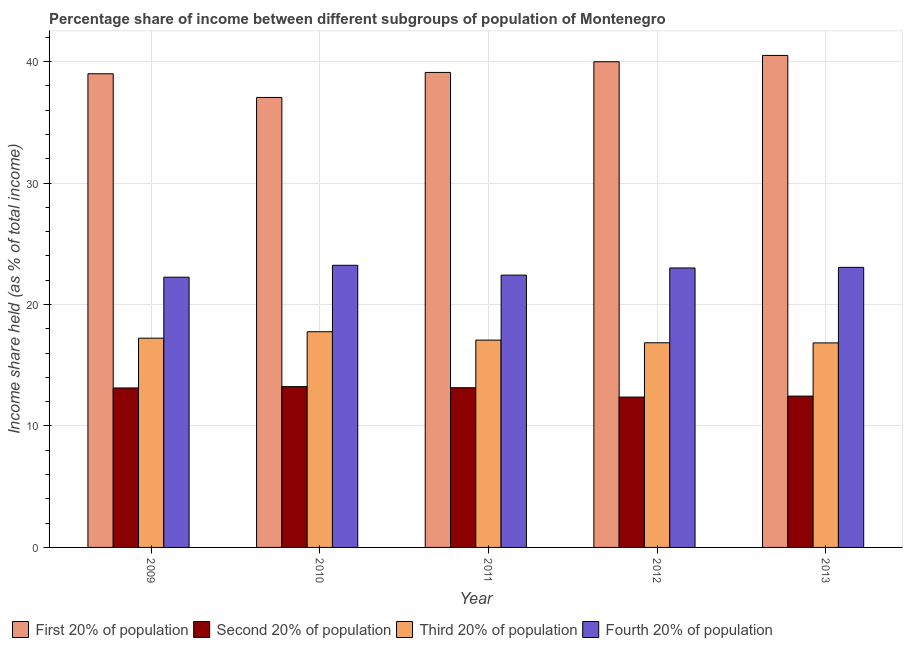How many different coloured bars are there?
Provide a succinct answer. 4. Are the number of bars per tick equal to the number of legend labels?
Keep it short and to the point. Yes. Are the number of bars on each tick of the X-axis equal?
Provide a short and direct response. Yes. How many bars are there on the 4th tick from the left?
Your response must be concise. 4. What is the label of the 4th group of bars from the left?
Provide a succinct answer. 2012. What is the share of the income held by first 20% of the population in 2013?
Keep it short and to the point. 40.51. Across all years, what is the maximum share of the income held by first 20% of the population?
Keep it short and to the point. 40.51. Across all years, what is the minimum share of the income held by first 20% of the population?
Your answer should be compact. 37.05. In which year was the share of the income held by fourth 20% of the population minimum?
Your answer should be very brief. 2009. What is the total share of the income held by third 20% of the population in the graph?
Give a very brief answer. 85.75. What is the difference between the share of the income held by fourth 20% of the population in 2012 and that in 2013?
Your answer should be very brief. -0.05. What is the difference between the share of the income held by fourth 20% of the population in 2012 and the share of the income held by first 20% of the population in 2013?
Offer a very short reply. -0.05. What is the average share of the income held by second 20% of the population per year?
Offer a very short reply. 12.87. In the year 2009, what is the difference between the share of the income held by first 20% of the population and share of the income held by fourth 20% of the population?
Your answer should be very brief. 0. In how many years, is the share of the income held by second 20% of the population greater than 38 %?
Offer a terse response. 0. What is the ratio of the share of the income held by fourth 20% of the population in 2012 to that in 2013?
Your response must be concise. 1. Is the share of the income held by first 20% of the population in 2009 less than that in 2012?
Offer a very short reply. Yes. What is the difference between the highest and the second highest share of the income held by first 20% of the population?
Your answer should be compact. 0.52. What is the difference between the highest and the lowest share of the income held by first 20% of the population?
Your response must be concise. 3.46. What does the 3rd bar from the left in 2013 represents?
Keep it short and to the point. Third 20% of population. What does the 1st bar from the right in 2011 represents?
Provide a short and direct response. Fourth 20% of population. How many bars are there?
Provide a succinct answer. 20. Are all the bars in the graph horizontal?
Keep it short and to the point. No. How many years are there in the graph?
Provide a succinct answer. 5. What is the difference between two consecutive major ticks on the Y-axis?
Your answer should be very brief. 10. Are the values on the major ticks of Y-axis written in scientific E-notation?
Offer a very short reply. No. How many legend labels are there?
Provide a short and direct response. 4. How are the legend labels stacked?
Your answer should be very brief. Horizontal. What is the title of the graph?
Offer a very short reply. Percentage share of income between different subgroups of population of Montenegro. What is the label or title of the Y-axis?
Keep it short and to the point. Income share held (as % of total income). What is the Income share held (as % of total income) of First 20% of population in 2009?
Offer a terse response. 39. What is the Income share held (as % of total income) of Second 20% of population in 2009?
Make the answer very short. 13.13. What is the Income share held (as % of total income) of Third 20% of population in 2009?
Your answer should be very brief. 17.23. What is the Income share held (as % of total income) in Fourth 20% of population in 2009?
Your response must be concise. 22.25. What is the Income share held (as % of total income) of First 20% of population in 2010?
Provide a short and direct response. 37.05. What is the Income share held (as % of total income) in Second 20% of population in 2010?
Ensure brevity in your answer.  13.24. What is the Income share held (as % of total income) of Third 20% of population in 2010?
Give a very brief answer. 17.76. What is the Income share held (as % of total income) of Fourth 20% of population in 2010?
Ensure brevity in your answer.  23.23. What is the Income share held (as % of total income) of First 20% of population in 2011?
Offer a very short reply. 39.11. What is the Income share held (as % of total income) in Second 20% of population in 2011?
Your answer should be very brief. 13.15. What is the Income share held (as % of total income) in Third 20% of population in 2011?
Your response must be concise. 17.07. What is the Income share held (as % of total income) in Fourth 20% of population in 2011?
Your answer should be compact. 22.42. What is the Income share held (as % of total income) of First 20% of population in 2012?
Ensure brevity in your answer.  39.99. What is the Income share held (as % of total income) in Second 20% of population in 2012?
Offer a terse response. 12.38. What is the Income share held (as % of total income) in Third 20% of population in 2012?
Your answer should be very brief. 16.85. What is the Income share held (as % of total income) of Fourth 20% of population in 2012?
Provide a short and direct response. 23.01. What is the Income share held (as % of total income) in First 20% of population in 2013?
Provide a succinct answer. 40.51. What is the Income share held (as % of total income) of Second 20% of population in 2013?
Make the answer very short. 12.46. What is the Income share held (as % of total income) of Third 20% of population in 2013?
Provide a short and direct response. 16.84. What is the Income share held (as % of total income) in Fourth 20% of population in 2013?
Ensure brevity in your answer.  23.06. Across all years, what is the maximum Income share held (as % of total income) in First 20% of population?
Offer a very short reply. 40.51. Across all years, what is the maximum Income share held (as % of total income) in Second 20% of population?
Your answer should be compact. 13.24. Across all years, what is the maximum Income share held (as % of total income) of Third 20% of population?
Offer a very short reply. 17.76. Across all years, what is the maximum Income share held (as % of total income) of Fourth 20% of population?
Keep it short and to the point. 23.23. Across all years, what is the minimum Income share held (as % of total income) of First 20% of population?
Your answer should be very brief. 37.05. Across all years, what is the minimum Income share held (as % of total income) of Second 20% of population?
Ensure brevity in your answer.  12.38. Across all years, what is the minimum Income share held (as % of total income) of Third 20% of population?
Offer a terse response. 16.84. Across all years, what is the minimum Income share held (as % of total income) in Fourth 20% of population?
Provide a succinct answer. 22.25. What is the total Income share held (as % of total income) in First 20% of population in the graph?
Keep it short and to the point. 195.66. What is the total Income share held (as % of total income) in Second 20% of population in the graph?
Provide a succinct answer. 64.36. What is the total Income share held (as % of total income) of Third 20% of population in the graph?
Make the answer very short. 85.75. What is the total Income share held (as % of total income) of Fourth 20% of population in the graph?
Give a very brief answer. 113.97. What is the difference between the Income share held (as % of total income) of First 20% of population in 2009 and that in 2010?
Give a very brief answer. 1.95. What is the difference between the Income share held (as % of total income) of Second 20% of population in 2009 and that in 2010?
Give a very brief answer. -0.11. What is the difference between the Income share held (as % of total income) of Third 20% of population in 2009 and that in 2010?
Provide a short and direct response. -0.53. What is the difference between the Income share held (as % of total income) in Fourth 20% of population in 2009 and that in 2010?
Your response must be concise. -0.98. What is the difference between the Income share held (as % of total income) in First 20% of population in 2009 and that in 2011?
Give a very brief answer. -0.11. What is the difference between the Income share held (as % of total income) in Second 20% of population in 2009 and that in 2011?
Offer a very short reply. -0.02. What is the difference between the Income share held (as % of total income) in Third 20% of population in 2009 and that in 2011?
Provide a short and direct response. 0.16. What is the difference between the Income share held (as % of total income) of Fourth 20% of population in 2009 and that in 2011?
Your response must be concise. -0.17. What is the difference between the Income share held (as % of total income) in First 20% of population in 2009 and that in 2012?
Offer a terse response. -0.99. What is the difference between the Income share held (as % of total income) in Third 20% of population in 2009 and that in 2012?
Provide a short and direct response. 0.38. What is the difference between the Income share held (as % of total income) of Fourth 20% of population in 2009 and that in 2012?
Give a very brief answer. -0.76. What is the difference between the Income share held (as % of total income) in First 20% of population in 2009 and that in 2013?
Provide a short and direct response. -1.51. What is the difference between the Income share held (as % of total income) in Second 20% of population in 2009 and that in 2013?
Provide a short and direct response. 0.67. What is the difference between the Income share held (as % of total income) in Third 20% of population in 2009 and that in 2013?
Provide a succinct answer. 0.39. What is the difference between the Income share held (as % of total income) in Fourth 20% of population in 2009 and that in 2013?
Keep it short and to the point. -0.81. What is the difference between the Income share held (as % of total income) in First 20% of population in 2010 and that in 2011?
Your answer should be compact. -2.06. What is the difference between the Income share held (as % of total income) in Second 20% of population in 2010 and that in 2011?
Keep it short and to the point. 0.09. What is the difference between the Income share held (as % of total income) of Third 20% of population in 2010 and that in 2011?
Offer a terse response. 0.69. What is the difference between the Income share held (as % of total income) of Fourth 20% of population in 2010 and that in 2011?
Offer a very short reply. 0.81. What is the difference between the Income share held (as % of total income) of First 20% of population in 2010 and that in 2012?
Offer a very short reply. -2.94. What is the difference between the Income share held (as % of total income) of Second 20% of population in 2010 and that in 2012?
Give a very brief answer. 0.86. What is the difference between the Income share held (as % of total income) of Third 20% of population in 2010 and that in 2012?
Keep it short and to the point. 0.91. What is the difference between the Income share held (as % of total income) of Fourth 20% of population in 2010 and that in 2012?
Your response must be concise. 0.22. What is the difference between the Income share held (as % of total income) in First 20% of population in 2010 and that in 2013?
Make the answer very short. -3.46. What is the difference between the Income share held (as % of total income) in Second 20% of population in 2010 and that in 2013?
Provide a succinct answer. 0.78. What is the difference between the Income share held (as % of total income) of Fourth 20% of population in 2010 and that in 2013?
Keep it short and to the point. 0.17. What is the difference between the Income share held (as % of total income) in First 20% of population in 2011 and that in 2012?
Make the answer very short. -0.88. What is the difference between the Income share held (as % of total income) in Second 20% of population in 2011 and that in 2012?
Give a very brief answer. 0.77. What is the difference between the Income share held (as % of total income) of Third 20% of population in 2011 and that in 2012?
Your answer should be compact. 0.22. What is the difference between the Income share held (as % of total income) of Fourth 20% of population in 2011 and that in 2012?
Keep it short and to the point. -0.59. What is the difference between the Income share held (as % of total income) of First 20% of population in 2011 and that in 2013?
Provide a succinct answer. -1.4. What is the difference between the Income share held (as % of total income) of Second 20% of population in 2011 and that in 2013?
Provide a short and direct response. 0.69. What is the difference between the Income share held (as % of total income) of Third 20% of population in 2011 and that in 2013?
Your answer should be compact. 0.23. What is the difference between the Income share held (as % of total income) of Fourth 20% of population in 2011 and that in 2013?
Make the answer very short. -0.64. What is the difference between the Income share held (as % of total income) of First 20% of population in 2012 and that in 2013?
Make the answer very short. -0.52. What is the difference between the Income share held (as % of total income) in Second 20% of population in 2012 and that in 2013?
Offer a terse response. -0.08. What is the difference between the Income share held (as % of total income) of Third 20% of population in 2012 and that in 2013?
Make the answer very short. 0.01. What is the difference between the Income share held (as % of total income) in First 20% of population in 2009 and the Income share held (as % of total income) in Second 20% of population in 2010?
Give a very brief answer. 25.76. What is the difference between the Income share held (as % of total income) of First 20% of population in 2009 and the Income share held (as % of total income) of Third 20% of population in 2010?
Your response must be concise. 21.24. What is the difference between the Income share held (as % of total income) of First 20% of population in 2009 and the Income share held (as % of total income) of Fourth 20% of population in 2010?
Your answer should be compact. 15.77. What is the difference between the Income share held (as % of total income) in Second 20% of population in 2009 and the Income share held (as % of total income) in Third 20% of population in 2010?
Make the answer very short. -4.63. What is the difference between the Income share held (as % of total income) of Third 20% of population in 2009 and the Income share held (as % of total income) of Fourth 20% of population in 2010?
Your answer should be very brief. -6. What is the difference between the Income share held (as % of total income) in First 20% of population in 2009 and the Income share held (as % of total income) in Second 20% of population in 2011?
Keep it short and to the point. 25.85. What is the difference between the Income share held (as % of total income) of First 20% of population in 2009 and the Income share held (as % of total income) of Third 20% of population in 2011?
Make the answer very short. 21.93. What is the difference between the Income share held (as % of total income) in First 20% of population in 2009 and the Income share held (as % of total income) in Fourth 20% of population in 2011?
Offer a terse response. 16.58. What is the difference between the Income share held (as % of total income) of Second 20% of population in 2009 and the Income share held (as % of total income) of Third 20% of population in 2011?
Your response must be concise. -3.94. What is the difference between the Income share held (as % of total income) in Second 20% of population in 2009 and the Income share held (as % of total income) in Fourth 20% of population in 2011?
Provide a short and direct response. -9.29. What is the difference between the Income share held (as % of total income) in Third 20% of population in 2009 and the Income share held (as % of total income) in Fourth 20% of population in 2011?
Give a very brief answer. -5.19. What is the difference between the Income share held (as % of total income) in First 20% of population in 2009 and the Income share held (as % of total income) in Second 20% of population in 2012?
Your response must be concise. 26.62. What is the difference between the Income share held (as % of total income) of First 20% of population in 2009 and the Income share held (as % of total income) of Third 20% of population in 2012?
Your response must be concise. 22.15. What is the difference between the Income share held (as % of total income) in First 20% of population in 2009 and the Income share held (as % of total income) in Fourth 20% of population in 2012?
Your response must be concise. 15.99. What is the difference between the Income share held (as % of total income) of Second 20% of population in 2009 and the Income share held (as % of total income) of Third 20% of population in 2012?
Ensure brevity in your answer.  -3.72. What is the difference between the Income share held (as % of total income) in Second 20% of population in 2009 and the Income share held (as % of total income) in Fourth 20% of population in 2012?
Offer a terse response. -9.88. What is the difference between the Income share held (as % of total income) in Third 20% of population in 2009 and the Income share held (as % of total income) in Fourth 20% of population in 2012?
Give a very brief answer. -5.78. What is the difference between the Income share held (as % of total income) in First 20% of population in 2009 and the Income share held (as % of total income) in Second 20% of population in 2013?
Keep it short and to the point. 26.54. What is the difference between the Income share held (as % of total income) in First 20% of population in 2009 and the Income share held (as % of total income) in Third 20% of population in 2013?
Your answer should be very brief. 22.16. What is the difference between the Income share held (as % of total income) of First 20% of population in 2009 and the Income share held (as % of total income) of Fourth 20% of population in 2013?
Provide a succinct answer. 15.94. What is the difference between the Income share held (as % of total income) in Second 20% of population in 2009 and the Income share held (as % of total income) in Third 20% of population in 2013?
Ensure brevity in your answer.  -3.71. What is the difference between the Income share held (as % of total income) in Second 20% of population in 2009 and the Income share held (as % of total income) in Fourth 20% of population in 2013?
Your response must be concise. -9.93. What is the difference between the Income share held (as % of total income) of Third 20% of population in 2009 and the Income share held (as % of total income) of Fourth 20% of population in 2013?
Offer a terse response. -5.83. What is the difference between the Income share held (as % of total income) in First 20% of population in 2010 and the Income share held (as % of total income) in Second 20% of population in 2011?
Your response must be concise. 23.9. What is the difference between the Income share held (as % of total income) in First 20% of population in 2010 and the Income share held (as % of total income) in Third 20% of population in 2011?
Your answer should be compact. 19.98. What is the difference between the Income share held (as % of total income) in First 20% of population in 2010 and the Income share held (as % of total income) in Fourth 20% of population in 2011?
Make the answer very short. 14.63. What is the difference between the Income share held (as % of total income) of Second 20% of population in 2010 and the Income share held (as % of total income) of Third 20% of population in 2011?
Make the answer very short. -3.83. What is the difference between the Income share held (as % of total income) of Second 20% of population in 2010 and the Income share held (as % of total income) of Fourth 20% of population in 2011?
Ensure brevity in your answer.  -9.18. What is the difference between the Income share held (as % of total income) in Third 20% of population in 2010 and the Income share held (as % of total income) in Fourth 20% of population in 2011?
Offer a terse response. -4.66. What is the difference between the Income share held (as % of total income) of First 20% of population in 2010 and the Income share held (as % of total income) of Second 20% of population in 2012?
Give a very brief answer. 24.67. What is the difference between the Income share held (as % of total income) in First 20% of population in 2010 and the Income share held (as % of total income) in Third 20% of population in 2012?
Provide a succinct answer. 20.2. What is the difference between the Income share held (as % of total income) of First 20% of population in 2010 and the Income share held (as % of total income) of Fourth 20% of population in 2012?
Give a very brief answer. 14.04. What is the difference between the Income share held (as % of total income) in Second 20% of population in 2010 and the Income share held (as % of total income) in Third 20% of population in 2012?
Offer a very short reply. -3.61. What is the difference between the Income share held (as % of total income) of Second 20% of population in 2010 and the Income share held (as % of total income) of Fourth 20% of population in 2012?
Make the answer very short. -9.77. What is the difference between the Income share held (as % of total income) in Third 20% of population in 2010 and the Income share held (as % of total income) in Fourth 20% of population in 2012?
Give a very brief answer. -5.25. What is the difference between the Income share held (as % of total income) of First 20% of population in 2010 and the Income share held (as % of total income) of Second 20% of population in 2013?
Provide a succinct answer. 24.59. What is the difference between the Income share held (as % of total income) of First 20% of population in 2010 and the Income share held (as % of total income) of Third 20% of population in 2013?
Your answer should be compact. 20.21. What is the difference between the Income share held (as % of total income) in First 20% of population in 2010 and the Income share held (as % of total income) in Fourth 20% of population in 2013?
Provide a succinct answer. 13.99. What is the difference between the Income share held (as % of total income) of Second 20% of population in 2010 and the Income share held (as % of total income) of Fourth 20% of population in 2013?
Offer a terse response. -9.82. What is the difference between the Income share held (as % of total income) of First 20% of population in 2011 and the Income share held (as % of total income) of Second 20% of population in 2012?
Offer a very short reply. 26.73. What is the difference between the Income share held (as % of total income) of First 20% of population in 2011 and the Income share held (as % of total income) of Third 20% of population in 2012?
Your response must be concise. 22.26. What is the difference between the Income share held (as % of total income) in First 20% of population in 2011 and the Income share held (as % of total income) in Fourth 20% of population in 2012?
Provide a short and direct response. 16.1. What is the difference between the Income share held (as % of total income) in Second 20% of population in 2011 and the Income share held (as % of total income) in Fourth 20% of population in 2012?
Offer a terse response. -9.86. What is the difference between the Income share held (as % of total income) in Third 20% of population in 2011 and the Income share held (as % of total income) in Fourth 20% of population in 2012?
Your response must be concise. -5.94. What is the difference between the Income share held (as % of total income) of First 20% of population in 2011 and the Income share held (as % of total income) of Second 20% of population in 2013?
Make the answer very short. 26.65. What is the difference between the Income share held (as % of total income) in First 20% of population in 2011 and the Income share held (as % of total income) in Third 20% of population in 2013?
Offer a terse response. 22.27. What is the difference between the Income share held (as % of total income) of First 20% of population in 2011 and the Income share held (as % of total income) of Fourth 20% of population in 2013?
Give a very brief answer. 16.05. What is the difference between the Income share held (as % of total income) of Second 20% of population in 2011 and the Income share held (as % of total income) of Third 20% of population in 2013?
Your answer should be very brief. -3.69. What is the difference between the Income share held (as % of total income) of Second 20% of population in 2011 and the Income share held (as % of total income) of Fourth 20% of population in 2013?
Give a very brief answer. -9.91. What is the difference between the Income share held (as % of total income) of Third 20% of population in 2011 and the Income share held (as % of total income) of Fourth 20% of population in 2013?
Your answer should be compact. -5.99. What is the difference between the Income share held (as % of total income) in First 20% of population in 2012 and the Income share held (as % of total income) in Second 20% of population in 2013?
Keep it short and to the point. 27.53. What is the difference between the Income share held (as % of total income) of First 20% of population in 2012 and the Income share held (as % of total income) of Third 20% of population in 2013?
Offer a very short reply. 23.15. What is the difference between the Income share held (as % of total income) of First 20% of population in 2012 and the Income share held (as % of total income) of Fourth 20% of population in 2013?
Give a very brief answer. 16.93. What is the difference between the Income share held (as % of total income) in Second 20% of population in 2012 and the Income share held (as % of total income) in Third 20% of population in 2013?
Keep it short and to the point. -4.46. What is the difference between the Income share held (as % of total income) in Second 20% of population in 2012 and the Income share held (as % of total income) in Fourth 20% of population in 2013?
Keep it short and to the point. -10.68. What is the difference between the Income share held (as % of total income) in Third 20% of population in 2012 and the Income share held (as % of total income) in Fourth 20% of population in 2013?
Make the answer very short. -6.21. What is the average Income share held (as % of total income) of First 20% of population per year?
Make the answer very short. 39.13. What is the average Income share held (as % of total income) in Second 20% of population per year?
Offer a very short reply. 12.87. What is the average Income share held (as % of total income) of Third 20% of population per year?
Make the answer very short. 17.15. What is the average Income share held (as % of total income) of Fourth 20% of population per year?
Offer a terse response. 22.79. In the year 2009, what is the difference between the Income share held (as % of total income) in First 20% of population and Income share held (as % of total income) in Second 20% of population?
Your answer should be very brief. 25.87. In the year 2009, what is the difference between the Income share held (as % of total income) in First 20% of population and Income share held (as % of total income) in Third 20% of population?
Keep it short and to the point. 21.77. In the year 2009, what is the difference between the Income share held (as % of total income) of First 20% of population and Income share held (as % of total income) of Fourth 20% of population?
Provide a short and direct response. 16.75. In the year 2009, what is the difference between the Income share held (as % of total income) of Second 20% of population and Income share held (as % of total income) of Fourth 20% of population?
Provide a succinct answer. -9.12. In the year 2009, what is the difference between the Income share held (as % of total income) of Third 20% of population and Income share held (as % of total income) of Fourth 20% of population?
Your answer should be very brief. -5.02. In the year 2010, what is the difference between the Income share held (as % of total income) of First 20% of population and Income share held (as % of total income) of Second 20% of population?
Your answer should be compact. 23.81. In the year 2010, what is the difference between the Income share held (as % of total income) of First 20% of population and Income share held (as % of total income) of Third 20% of population?
Your response must be concise. 19.29. In the year 2010, what is the difference between the Income share held (as % of total income) in First 20% of population and Income share held (as % of total income) in Fourth 20% of population?
Make the answer very short. 13.82. In the year 2010, what is the difference between the Income share held (as % of total income) of Second 20% of population and Income share held (as % of total income) of Third 20% of population?
Make the answer very short. -4.52. In the year 2010, what is the difference between the Income share held (as % of total income) of Second 20% of population and Income share held (as % of total income) of Fourth 20% of population?
Give a very brief answer. -9.99. In the year 2010, what is the difference between the Income share held (as % of total income) of Third 20% of population and Income share held (as % of total income) of Fourth 20% of population?
Keep it short and to the point. -5.47. In the year 2011, what is the difference between the Income share held (as % of total income) of First 20% of population and Income share held (as % of total income) of Second 20% of population?
Offer a very short reply. 25.96. In the year 2011, what is the difference between the Income share held (as % of total income) in First 20% of population and Income share held (as % of total income) in Third 20% of population?
Keep it short and to the point. 22.04. In the year 2011, what is the difference between the Income share held (as % of total income) in First 20% of population and Income share held (as % of total income) in Fourth 20% of population?
Offer a terse response. 16.69. In the year 2011, what is the difference between the Income share held (as % of total income) of Second 20% of population and Income share held (as % of total income) of Third 20% of population?
Offer a very short reply. -3.92. In the year 2011, what is the difference between the Income share held (as % of total income) in Second 20% of population and Income share held (as % of total income) in Fourth 20% of population?
Provide a succinct answer. -9.27. In the year 2011, what is the difference between the Income share held (as % of total income) in Third 20% of population and Income share held (as % of total income) in Fourth 20% of population?
Your answer should be compact. -5.35. In the year 2012, what is the difference between the Income share held (as % of total income) in First 20% of population and Income share held (as % of total income) in Second 20% of population?
Offer a terse response. 27.61. In the year 2012, what is the difference between the Income share held (as % of total income) of First 20% of population and Income share held (as % of total income) of Third 20% of population?
Provide a succinct answer. 23.14. In the year 2012, what is the difference between the Income share held (as % of total income) in First 20% of population and Income share held (as % of total income) in Fourth 20% of population?
Offer a very short reply. 16.98. In the year 2012, what is the difference between the Income share held (as % of total income) in Second 20% of population and Income share held (as % of total income) in Third 20% of population?
Ensure brevity in your answer.  -4.47. In the year 2012, what is the difference between the Income share held (as % of total income) in Second 20% of population and Income share held (as % of total income) in Fourth 20% of population?
Offer a terse response. -10.63. In the year 2012, what is the difference between the Income share held (as % of total income) in Third 20% of population and Income share held (as % of total income) in Fourth 20% of population?
Provide a short and direct response. -6.16. In the year 2013, what is the difference between the Income share held (as % of total income) in First 20% of population and Income share held (as % of total income) in Second 20% of population?
Give a very brief answer. 28.05. In the year 2013, what is the difference between the Income share held (as % of total income) in First 20% of population and Income share held (as % of total income) in Third 20% of population?
Ensure brevity in your answer.  23.67. In the year 2013, what is the difference between the Income share held (as % of total income) of First 20% of population and Income share held (as % of total income) of Fourth 20% of population?
Make the answer very short. 17.45. In the year 2013, what is the difference between the Income share held (as % of total income) of Second 20% of population and Income share held (as % of total income) of Third 20% of population?
Your answer should be very brief. -4.38. In the year 2013, what is the difference between the Income share held (as % of total income) in Third 20% of population and Income share held (as % of total income) in Fourth 20% of population?
Your answer should be very brief. -6.22. What is the ratio of the Income share held (as % of total income) of First 20% of population in 2009 to that in 2010?
Your answer should be compact. 1.05. What is the ratio of the Income share held (as % of total income) of Second 20% of population in 2009 to that in 2010?
Make the answer very short. 0.99. What is the ratio of the Income share held (as % of total income) in Third 20% of population in 2009 to that in 2010?
Give a very brief answer. 0.97. What is the ratio of the Income share held (as % of total income) in Fourth 20% of population in 2009 to that in 2010?
Your answer should be compact. 0.96. What is the ratio of the Income share held (as % of total income) in First 20% of population in 2009 to that in 2011?
Offer a terse response. 1. What is the ratio of the Income share held (as % of total income) in Second 20% of population in 2009 to that in 2011?
Provide a succinct answer. 1. What is the ratio of the Income share held (as % of total income) of Third 20% of population in 2009 to that in 2011?
Your answer should be compact. 1.01. What is the ratio of the Income share held (as % of total income) in Fourth 20% of population in 2009 to that in 2011?
Ensure brevity in your answer.  0.99. What is the ratio of the Income share held (as % of total income) of First 20% of population in 2009 to that in 2012?
Keep it short and to the point. 0.98. What is the ratio of the Income share held (as % of total income) in Second 20% of population in 2009 to that in 2012?
Give a very brief answer. 1.06. What is the ratio of the Income share held (as % of total income) of Third 20% of population in 2009 to that in 2012?
Your answer should be very brief. 1.02. What is the ratio of the Income share held (as % of total income) of Fourth 20% of population in 2009 to that in 2012?
Your response must be concise. 0.97. What is the ratio of the Income share held (as % of total income) in First 20% of population in 2009 to that in 2013?
Your answer should be compact. 0.96. What is the ratio of the Income share held (as % of total income) of Second 20% of population in 2009 to that in 2013?
Your answer should be very brief. 1.05. What is the ratio of the Income share held (as % of total income) of Third 20% of population in 2009 to that in 2013?
Provide a succinct answer. 1.02. What is the ratio of the Income share held (as % of total income) of Fourth 20% of population in 2009 to that in 2013?
Your answer should be compact. 0.96. What is the ratio of the Income share held (as % of total income) of First 20% of population in 2010 to that in 2011?
Make the answer very short. 0.95. What is the ratio of the Income share held (as % of total income) in Second 20% of population in 2010 to that in 2011?
Offer a terse response. 1.01. What is the ratio of the Income share held (as % of total income) of Third 20% of population in 2010 to that in 2011?
Ensure brevity in your answer.  1.04. What is the ratio of the Income share held (as % of total income) in Fourth 20% of population in 2010 to that in 2011?
Keep it short and to the point. 1.04. What is the ratio of the Income share held (as % of total income) of First 20% of population in 2010 to that in 2012?
Provide a succinct answer. 0.93. What is the ratio of the Income share held (as % of total income) of Second 20% of population in 2010 to that in 2012?
Provide a short and direct response. 1.07. What is the ratio of the Income share held (as % of total income) of Third 20% of population in 2010 to that in 2012?
Provide a short and direct response. 1.05. What is the ratio of the Income share held (as % of total income) of Fourth 20% of population in 2010 to that in 2012?
Offer a terse response. 1.01. What is the ratio of the Income share held (as % of total income) in First 20% of population in 2010 to that in 2013?
Give a very brief answer. 0.91. What is the ratio of the Income share held (as % of total income) of Second 20% of population in 2010 to that in 2013?
Make the answer very short. 1.06. What is the ratio of the Income share held (as % of total income) of Third 20% of population in 2010 to that in 2013?
Offer a very short reply. 1.05. What is the ratio of the Income share held (as % of total income) of Fourth 20% of population in 2010 to that in 2013?
Make the answer very short. 1.01. What is the ratio of the Income share held (as % of total income) of First 20% of population in 2011 to that in 2012?
Your answer should be compact. 0.98. What is the ratio of the Income share held (as % of total income) of Second 20% of population in 2011 to that in 2012?
Provide a short and direct response. 1.06. What is the ratio of the Income share held (as % of total income) in Third 20% of population in 2011 to that in 2012?
Your response must be concise. 1.01. What is the ratio of the Income share held (as % of total income) in Fourth 20% of population in 2011 to that in 2012?
Your answer should be compact. 0.97. What is the ratio of the Income share held (as % of total income) in First 20% of population in 2011 to that in 2013?
Keep it short and to the point. 0.97. What is the ratio of the Income share held (as % of total income) in Second 20% of population in 2011 to that in 2013?
Offer a very short reply. 1.06. What is the ratio of the Income share held (as % of total income) in Third 20% of population in 2011 to that in 2013?
Provide a short and direct response. 1.01. What is the ratio of the Income share held (as % of total income) in Fourth 20% of population in 2011 to that in 2013?
Provide a succinct answer. 0.97. What is the ratio of the Income share held (as % of total income) in First 20% of population in 2012 to that in 2013?
Your response must be concise. 0.99. What is the difference between the highest and the second highest Income share held (as % of total income) in First 20% of population?
Your answer should be very brief. 0.52. What is the difference between the highest and the second highest Income share held (as % of total income) of Second 20% of population?
Offer a terse response. 0.09. What is the difference between the highest and the second highest Income share held (as % of total income) in Third 20% of population?
Ensure brevity in your answer.  0.53. What is the difference between the highest and the second highest Income share held (as % of total income) in Fourth 20% of population?
Your answer should be compact. 0.17. What is the difference between the highest and the lowest Income share held (as % of total income) of First 20% of population?
Ensure brevity in your answer.  3.46. What is the difference between the highest and the lowest Income share held (as % of total income) of Second 20% of population?
Your answer should be very brief. 0.86. What is the difference between the highest and the lowest Income share held (as % of total income) in Fourth 20% of population?
Make the answer very short. 0.98. 